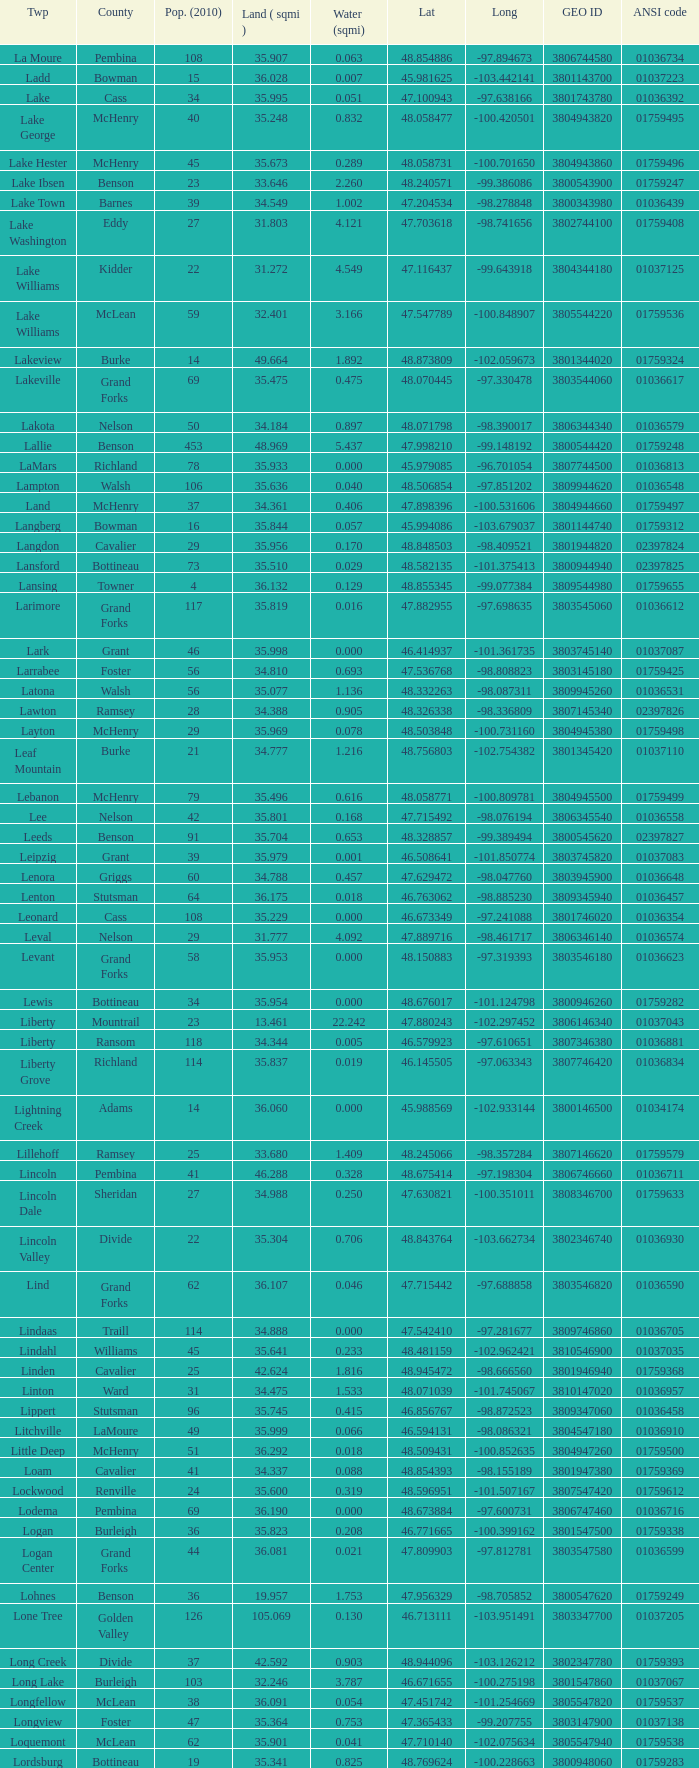What is latitude when 2010 population is 24 and water is more than 0.319? None. Could you parse the entire table as a dict? {'header': ['Twp', 'County', 'Pop. (2010)', 'Land ( sqmi )', 'Water (sqmi)', 'Lat', 'Long', 'GEO ID', 'ANSI code'], 'rows': [['La Moure', 'Pembina', '108', '35.907', '0.063', '48.854886', '-97.894673', '3806744580', '01036734'], ['Ladd', 'Bowman', '15', '36.028', '0.007', '45.981625', '-103.442141', '3801143700', '01037223'], ['Lake', 'Cass', '34', '35.995', '0.051', '47.100943', '-97.638166', '3801743780', '01036392'], ['Lake George', 'McHenry', '40', '35.248', '0.832', '48.058477', '-100.420501', '3804943820', '01759495'], ['Lake Hester', 'McHenry', '45', '35.673', '0.289', '48.058731', '-100.701650', '3804943860', '01759496'], ['Lake Ibsen', 'Benson', '23', '33.646', '2.260', '48.240571', '-99.386086', '3800543900', '01759247'], ['Lake Town', 'Barnes', '39', '34.549', '1.002', '47.204534', '-98.278848', '3800343980', '01036439'], ['Lake Washington', 'Eddy', '27', '31.803', '4.121', '47.703618', '-98.741656', '3802744100', '01759408'], ['Lake Williams', 'Kidder', '22', '31.272', '4.549', '47.116437', '-99.643918', '3804344180', '01037125'], ['Lake Williams', 'McLean', '59', '32.401', '3.166', '47.547789', '-100.848907', '3805544220', '01759536'], ['Lakeview', 'Burke', '14', '49.664', '1.892', '48.873809', '-102.059673', '3801344020', '01759324'], ['Lakeville', 'Grand Forks', '69', '35.475', '0.475', '48.070445', '-97.330478', '3803544060', '01036617'], ['Lakota', 'Nelson', '50', '34.184', '0.897', '48.071798', '-98.390017', '3806344340', '01036579'], ['Lallie', 'Benson', '453', '48.969', '5.437', '47.998210', '-99.148192', '3800544420', '01759248'], ['LaMars', 'Richland', '78', '35.933', '0.000', '45.979085', '-96.701054', '3807744500', '01036813'], ['Lampton', 'Walsh', '106', '35.636', '0.040', '48.506854', '-97.851202', '3809944620', '01036548'], ['Land', 'McHenry', '37', '34.361', '0.406', '47.898396', '-100.531606', '3804944660', '01759497'], ['Langberg', 'Bowman', '16', '35.844', '0.057', '45.994086', '-103.679037', '3801144740', '01759312'], ['Langdon', 'Cavalier', '29', '35.956', '0.170', '48.848503', '-98.409521', '3801944820', '02397824'], ['Lansford', 'Bottineau', '73', '35.510', '0.029', '48.582135', '-101.375413', '3800944940', '02397825'], ['Lansing', 'Towner', '4', '36.132', '0.129', '48.855345', '-99.077384', '3809544980', '01759655'], ['Larimore', 'Grand Forks', '117', '35.819', '0.016', '47.882955', '-97.698635', '3803545060', '01036612'], ['Lark', 'Grant', '46', '35.998', '0.000', '46.414937', '-101.361735', '3803745140', '01037087'], ['Larrabee', 'Foster', '56', '34.810', '0.693', '47.536768', '-98.808823', '3803145180', '01759425'], ['Latona', 'Walsh', '56', '35.077', '1.136', '48.332263', '-98.087311', '3809945260', '01036531'], ['Lawton', 'Ramsey', '28', '34.388', '0.905', '48.326338', '-98.336809', '3807145340', '02397826'], ['Layton', 'McHenry', '29', '35.969', '0.078', '48.503848', '-100.731160', '3804945380', '01759498'], ['Leaf Mountain', 'Burke', '21', '34.777', '1.216', '48.756803', '-102.754382', '3801345420', '01037110'], ['Lebanon', 'McHenry', '79', '35.496', '0.616', '48.058771', '-100.809781', '3804945500', '01759499'], ['Lee', 'Nelson', '42', '35.801', '0.168', '47.715492', '-98.076194', '3806345540', '01036558'], ['Leeds', 'Benson', '91', '35.704', '0.653', '48.328857', '-99.389494', '3800545620', '02397827'], ['Leipzig', 'Grant', '39', '35.979', '0.001', '46.508641', '-101.850774', '3803745820', '01037083'], ['Lenora', 'Griggs', '60', '34.788', '0.457', '47.629472', '-98.047760', '3803945900', '01036648'], ['Lenton', 'Stutsman', '64', '36.175', '0.018', '46.763062', '-98.885230', '3809345940', '01036457'], ['Leonard', 'Cass', '108', '35.229', '0.000', '46.673349', '-97.241088', '3801746020', '01036354'], ['Leval', 'Nelson', '29', '31.777', '4.092', '47.889716', '-98.461717', '3806346140', '01036574'], ['Levant', 'Grand Forks', '58', '35.953', '0.000', '48.150883', '-97.319393', '3803546180', '01036623'], ['Lewis', 'Bottineau', '34', '35.954', '0.000', '48.676017', '-101.124798', '3800946260', '01759282'], ['Liberty', 'Mountrail', '23', '13.461', '22.242', '47.880243', '-102.297452', '3806146340', '01037043'], ['Liberty', 'Ransom', '118', '34.344', '0.005', '46.579923', '-97.610651', '3807346380', '01036881'], ['Liberty Grove', 'Richland', '114', '35.837', '0.019', '46.145505', '-97.063343', '3807746420', '01036834'], ['Lightning Creek', 'Adams', '14', '36.060', '0.000', '45.988569', '-102.933144', '3800146500', '01034174'], ['Lillehoff', 'Ramsey', '25', '33.680', '1.409', '48.245066', '-98.357284', '3807146620', '01759579'], ['Lincoln', 'Pembina', '41', '46.288', '0.328', '48.675414', '-97.198304', '3806746660', '01036711'], ['Lincoln Dale', 'Sheridan', '27', '34.988', '0.250', '47.630821', '-100.351011', '3808346700', '01759633'], ['Lincoln Valley', 'Divide', '22', '35.304', '0.706', '48.843764', '-103.662734', '3802346740', '01036930'], ['Lind', 'Grand Forks', '62', '36.107', '0.046', '47.715442', '-97.688858', '3803546820', '01036590'], ['Lindaas', 'Traill', '114', '34.888', '0.000', '47.542410', '-97.281677', '3809746860', '01036705'], ['Lindahl', 'Williams', '45', '35.641', '0.233', '48.481159', '-102.962421', '3810546900', '01037035'], ['Linden', 'Cavalier', '25', '42.624', '1.816', '48.945472', '-98.666560', '3801946940', '01759368'], ['Linton', 'Ward', '31', '34.475', '1.533', '48.071039', '-101.745067', '3810147020', '01036957'], ['Lippert', 'Stutsman', '96', '35.745', '0.415', '46.856767', '-98.872523', '3809347060', '01036458'], ['Litchville', 'LaMoure', '49', '35.999', '0.066', '46.594131', '-98.086321', '3804547180', '01036910'], ['Little Deep', 'McHenry', '51', '36.292', '0.018', '48.509431', '-100.852635', '3804947260', '01759500'], ['Loam', 'Cavalier', '41', '34.337', '0.088', '48.854393', '-98.155189', '3801947380', '01759369'], ['Lockwood', 'Renville', '24', '35.600', '0.319', '48.596951', '-101.507167', '3807547420', '01759612'], ['Lodema', 'Pembina', '69', '36.190', '0.000', '48.673884', '-97.600731', '3806747460', '01036716'], ['Logan', 'Burleigh', '36', '35.823', '0.208', '46.771665', '-100.399162', '3801547500', '01759338'], ['Logan Center', 'Grand Forks', '44', '36.081', '0.021', '47.809903', '-97.812781', '3803547580', '01036599'], ['Lohnes', 'Benson', '36', '19.957', '1.753', '47.956329', '-98.705852', '3800547620', '01759249'], ['Lone Tree', 'Golden Valley', '126', '105.069', '0.130', '46.713111', '-103.951491', '3803347700', '01037205'], ['Long Creek', 'Divide', '37', '42.592', '0.903', '48.944096', '-103.126212', '3802347780', '01759393'], ['Long Lake', 'Burleigh', '103', '32.246', '3.787', '46.671655', '-100.275198', '3801547860', '01037067'], ['Longfellow', 'McLean', '38', '36.091', '0.054', '47.451742', '-101.254669', '3805547820', '01759537'], ['Longview', 'Foster', '47', '35.364', '0.753', '47.365433', '-99.207755', '3803147900', '01037138'], ['Loquemont', 'McLean', '62', '35.901', '0.041', '47.710140', '-102.075634', '3805547940', '01759538'], ['Lordsburg', 'Bottineau', '19', '35.341', '0.825', '48.769624', '-100.228663', '3800948060', '01759283'], ['Loretta', 'Grand Forks', '50', '36.138', '0.000', '47.715705', '-97.817996', '3803548100', '01036591'], ['Lorraine', 'Dickey', '35', '35.611', '0.028', '45.986327', '-98.824337', '3802148140', '01036749'], ['Lostwood', 'Mountrail', '40', '34.276', '1.569', '48.503029', '-102.419021', '3806148220', '01037117'], ['Lovell', 'Dickey', '42', '43.572', '0.484', '45.979477', '-98.080806', '3802148260', '01036742'], ['Lowery', 'Stutsman', '33', '34.212', '1.111', '47.285621', '-99.424886', '3809348300', '01037187'], ['Lowland', 'Mountrail', '52', '34.469', '1.610', '48.506983', '-102.025237', '3806148340', '01036980'], ['Lucy', 'Burke', '27', '34.394', '1.692', '48.690915', '-102.549425', '3801348420', '01759325'], ['Lund', 'Ward', '50', '34.796', '1.204', '48.059167', '-101.846052', '3810148500', '01036940'], ['Lynn', 'Wells', '21', '34.710', '1.455', '47.370988', '-99.979621', '3810348660', '01037155'], ['Lyon', 'Stutsman', '19', '33.030', '2.818', '47.195251', '-98.784930', '3809348740', '01036500']]} 